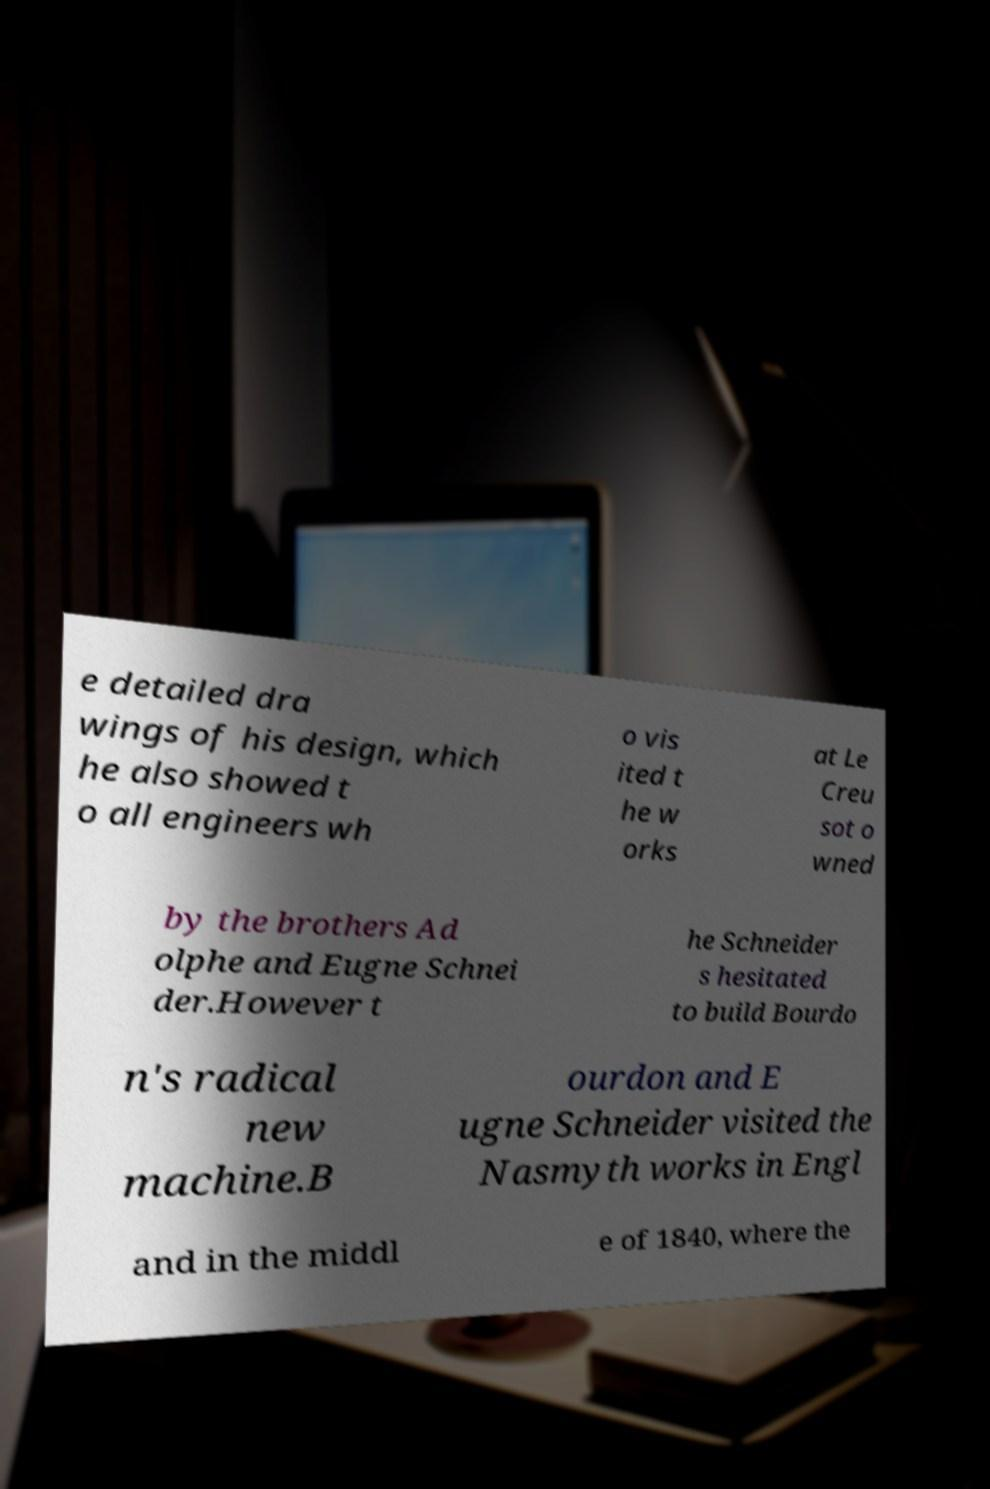Could you assist in decoding the text presented in this image and type it out clearly? e detailed dra wings of his design, which he also showed t o all engineers wh o vis ited t he w orks at Le Creu sot o wned by the brothers Ad olphe and Eugne Schnei der.However t he Schneider s hesitated to build Bourdo n's radical new machine.B ourdon and E ugne Schneider visited the Nasmyth works in Engl and in the middl e of 1840, where the 